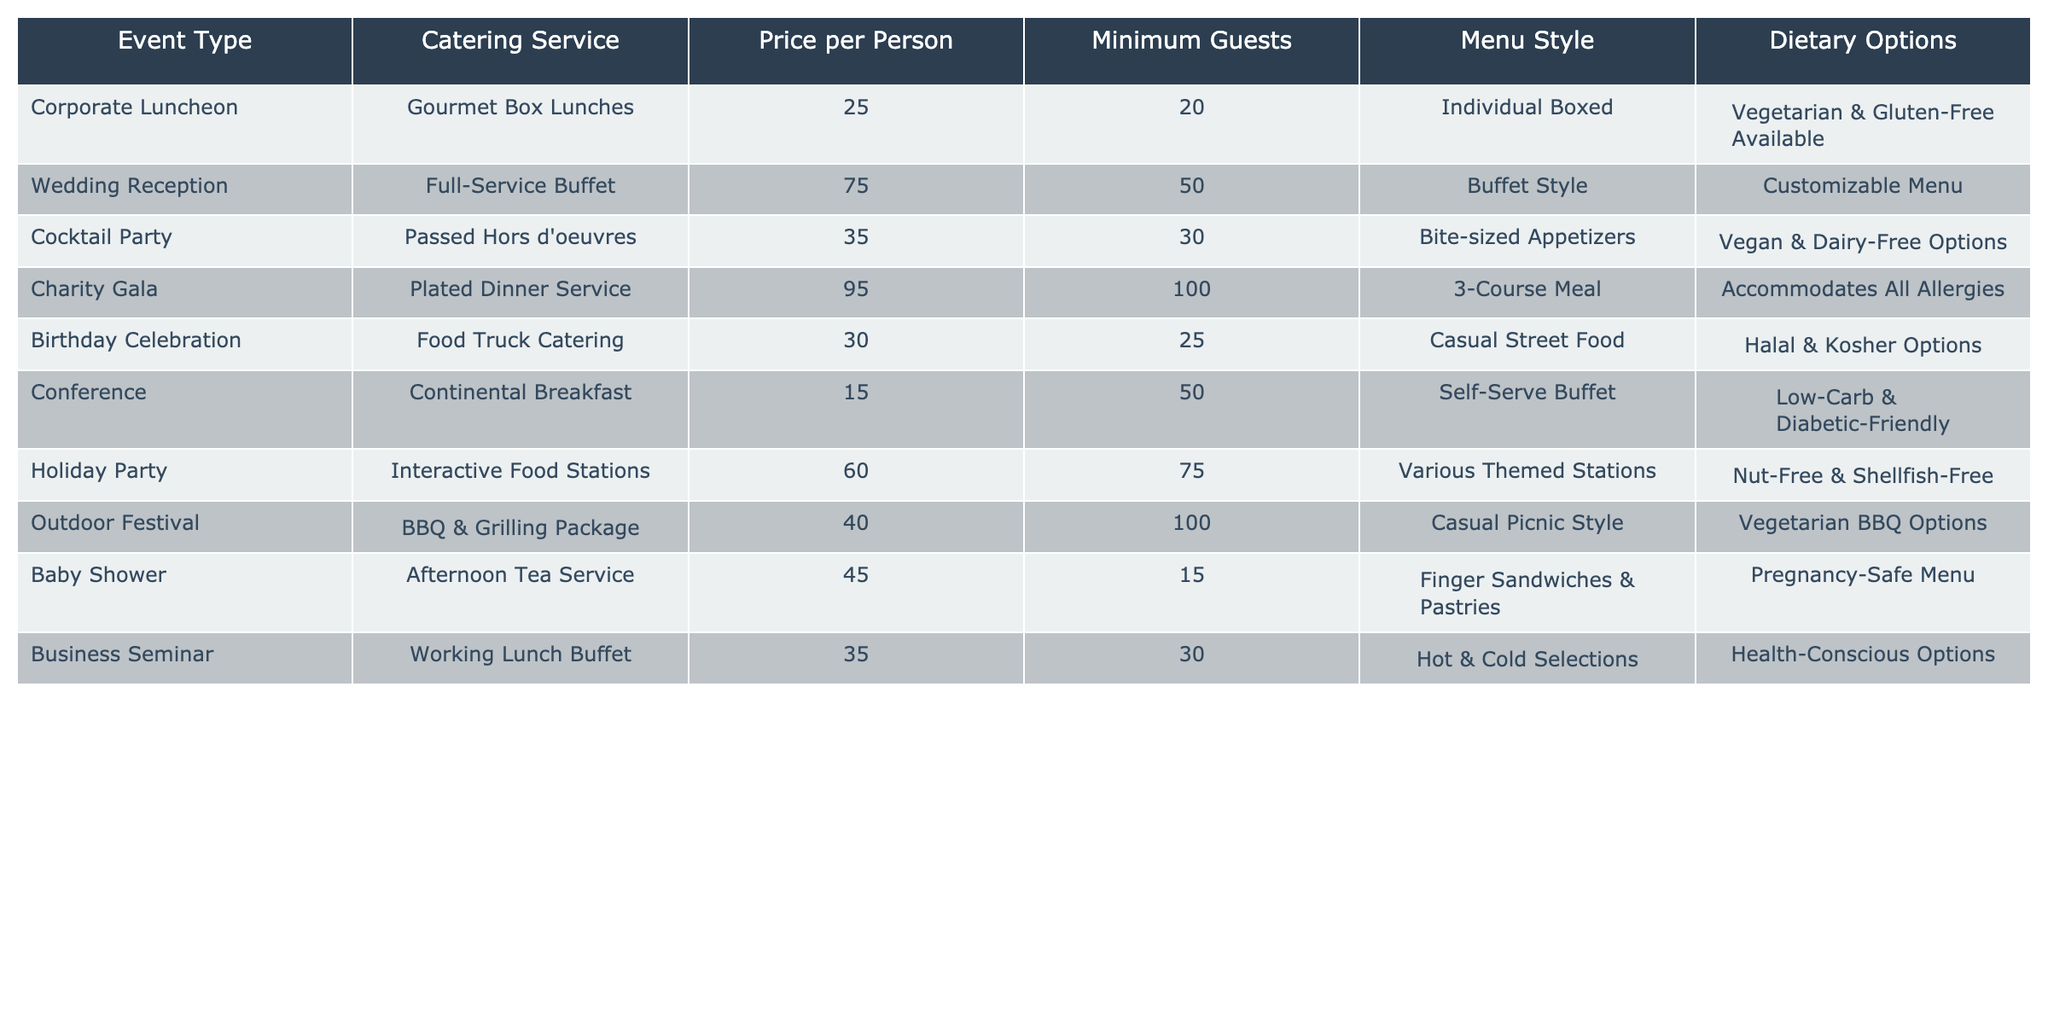What is the price per person for a corporate luncheon? The table lists the catering options for various event types. For the corporate luncheon, the price per person is directly stated as 25.
Answer: 25 How many minimum guests are required for a wedding reception? The table indicates that the minimum number of guests for a wedding reception is listed under the "Minimum Guests" column, which shows 50.
Answer: 50 Is there a catering service that accommodates all allergies? The "Charity Gala" event type mentions that it accommodates all allergies, confirming that there is a catering option that meets this criterion.
Answer: Yes What is the average price per person for the events listed? To find the average price, we first sum the prices per person: (25 + 75 + 35 + 95 + 30 + 15 + 60 + 40 + 45 + 35) which equals 455. There are 10 events in total, so the average price is 455/10 = 45.5.
Answer: 45.5 How many event types are there that require a minimum of 100 guests? By reviewing the "Minimum Guests" column, we can see that only the "Charity Gala" and "Outdoor Festival" require at least 100 guests, making it two event types.
Answer: 2 What dietary options are available for the food truck catering? The "Food Truck Catering" option for a birthday celebration specifically states that it offers Halal and Kosher options, which are the available dietary options for that event type.
Answer: Halal & Kosher Options Which event type has the highest price per person, and what is that price? The table shows that the "Charity Gala" has the highest price per person at 95, as confirmed by comparing the prices for each event type.
Answer: 95 What menu style is offered for the working lunch buffet? Referring to the table, the "Business Seminar" event type lists the menu style for its buffet as Hot & Cold Selections, specifying the style offered.
Answer: Hot & Cold Selections 